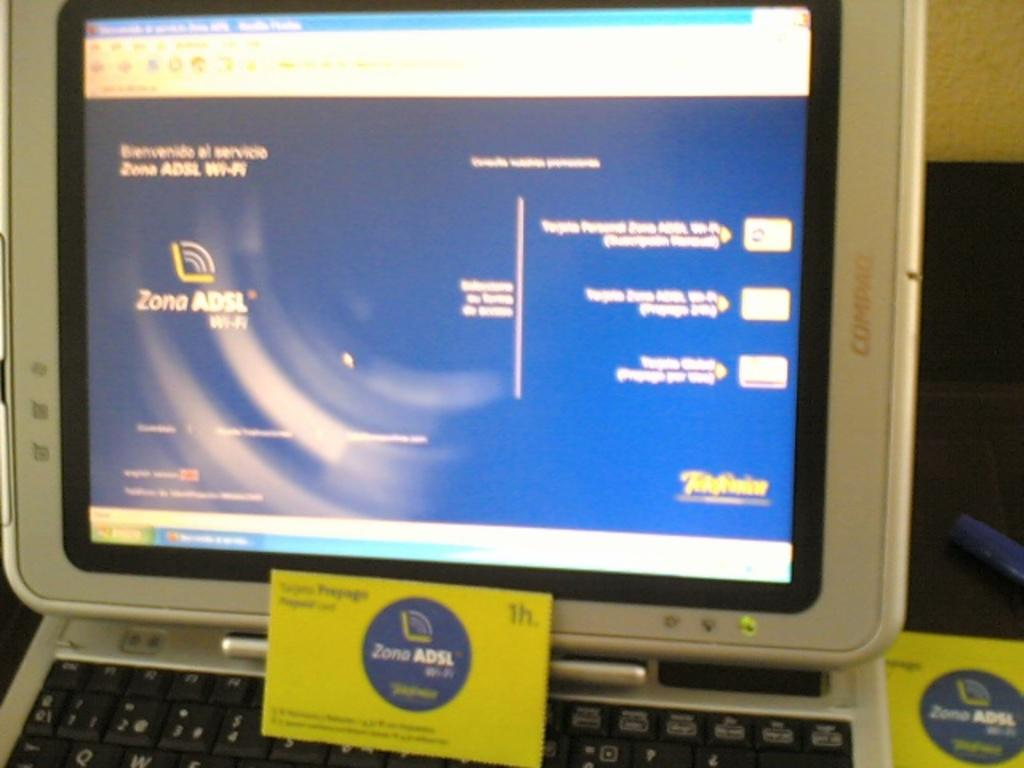<image>
Create a compact narrative representing the image presented. the word zona is on the purple sticker and screen 